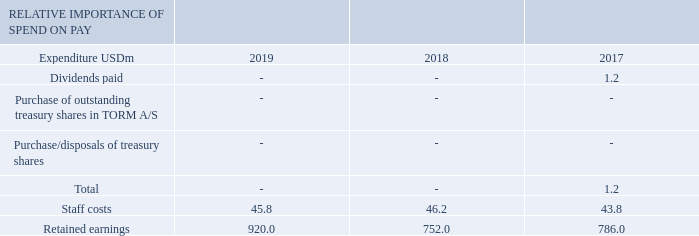REMUNERATION COMMITTEE REPORT
The table above shows the actual expenditure of the Group for employee pay and distributions to shareholders compared to the retained earnings of the Group.
What does the information in the table show? The actual expenditure of the group for employee pay and distributions to shareholders compared to the retained earnings of the group. What is the retained earnings for 2019?
Answer scale should be: million. 920.0. For which years is the actual expenditure of the Group for employee pay and distributions to shareholders compared to the retained earnings of the Group in the table? 2019, 2018, 2017. In which year were the staff costs the largest? 46.2>45.8>43.8
Answer: 2018. What was the change in retained earnings in 2019 from 2018?
Answer scale should be: million. 920.0-752.0
Answer: 168. What was the percentage change in retained earnings in 2019 from 2018?
Answer scale should be: percent. (920.0-752.0)/752.0
Answer: 22.34. 